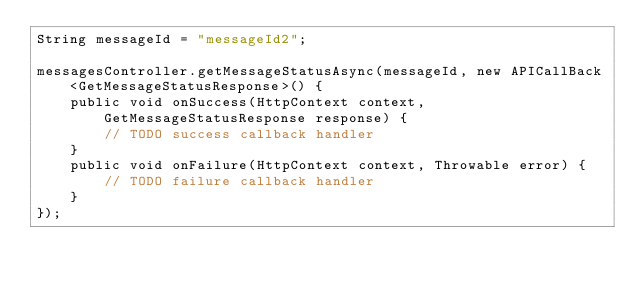<code> <loc_0><loc_0><loc_500><loc_500><_Java_>String messageId = "messageId2";

messagesController.getMessageStatusAsync(messageId, new APICallBack<GetMessageStatusResponse>() {
    public void onSuccess(HttpContext context, GetMessageStatusResponse response) {
        // TODO success callback handler
    }
    public void onFailure(HttpContext context, Throwable error) {
        // TODO failure callback handler
    }
});</code> 